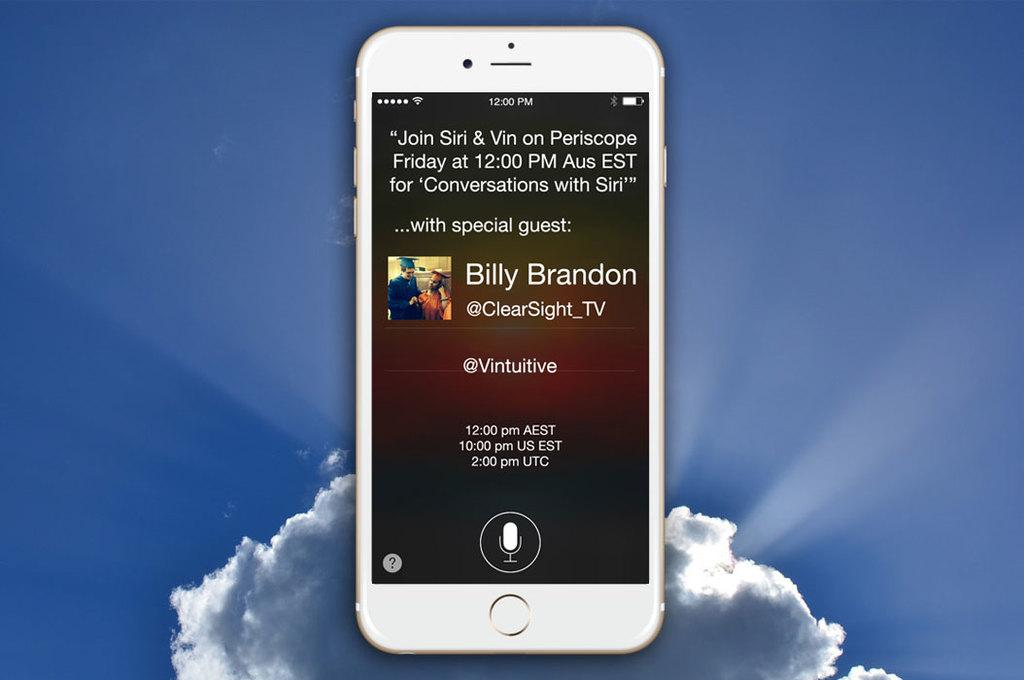<image>
Render a clear and concise summary of the photo. A iphone showing a periscope Friday at 12:00 PM Aus. with Billy Brandon. 